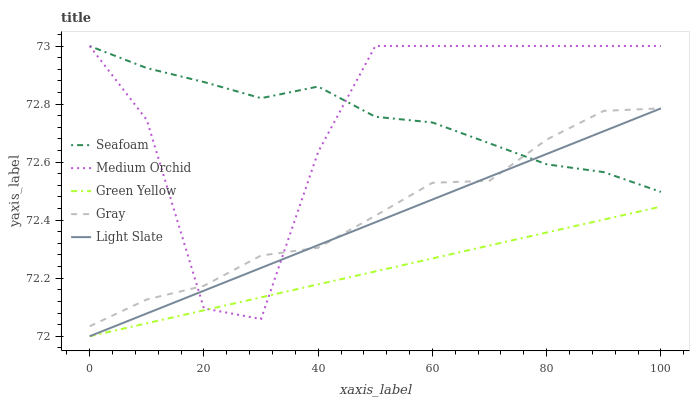Does Green Yellow have the minimum area under the curve?
Answer yes or no. Yes. Does Seafoam have the maximum area under the curve?
Answer yes or no. Yes. Does Gray have the minimum area under the curve?
Answer yes or no. No. Does Gray have the maximum area under the curve?
Answer yes or no. No. Is Light Slate the smoothest?
Answer yes or no. Yes. Is Medium Orchid the roughest?
Answer yes or no. Yes. Is Gray the smoothest?
Answer yes or no. No. Is Gray the roughest?
Answer yes or no. No. Does Gray have the lowest value?
Answer yes or no. No. Does Seafoam have the highest value?
Answer yes or no. Yes. Does Gray have the highest value?
Answer yes or no. No. Is Green Yellow less than Gray?
Answer yes or no. Yes. Is Seafoam greater than Green Yellow?
Answer yes or no. Yes. Does Green Yellow intersect Gray?
Answer yes or no. No. 